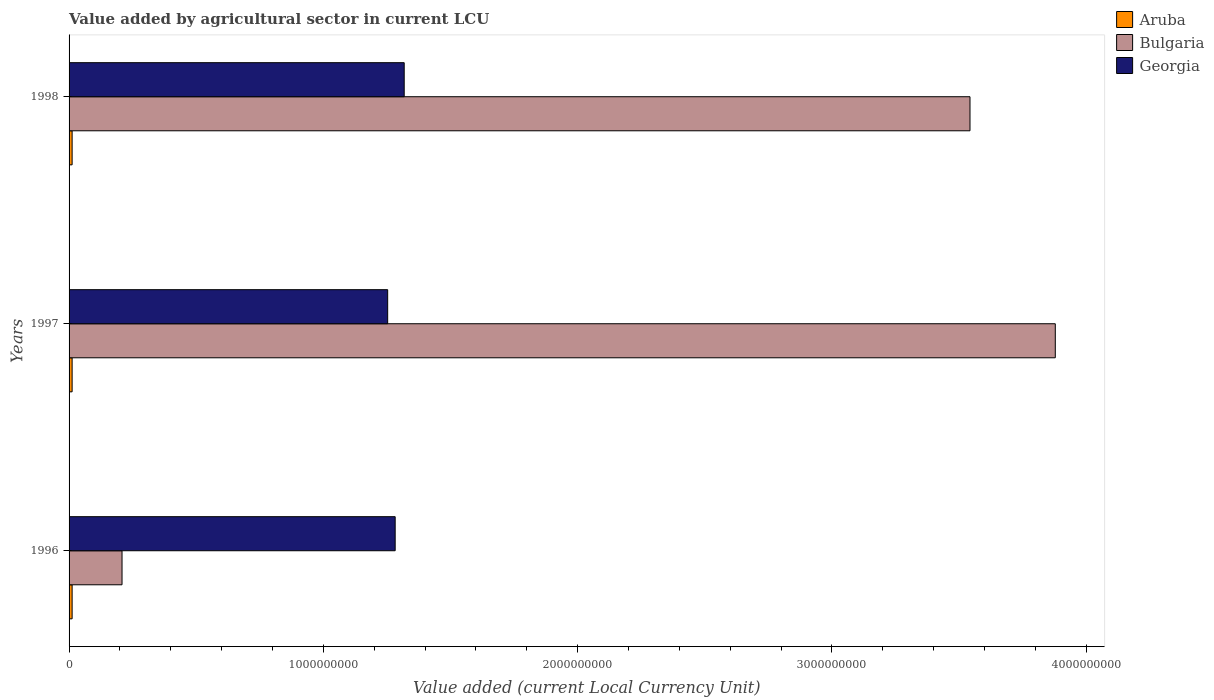How many different coloured bars are there?
Ensure brevity in your answer.  3. How many groups of bars are there?
Provide a succinct answer. 3. Are the number of bars per tick equal to the number of legend labels?
Offer a very short reply. Yes. Are the number of bars on each tick of the Y-axis equal?
Give a very brief answer. Yes. How many bars are there on the 1st tick from the top?
Your response must be concise. 3. What is the label of the 2nd group of bars from the top?
Provide a short and direct response. 1997. What is the value added by agricultural sector in Bulgaria in 1996?
Offer a very short reply. 2.08e+08. In which year was the value added by agricultural sector in Georgia maximum?
Keep it short and to the point. 1998. In which year was the value added by agricultural sector in Georgia minimum?
Ensure brevity in your answer.  1997. What is the total value added by agricultural sector in Bulgaria in the graph?
Provide a succinct answer. 7.63e+09. What is the difference between the value added by agricultural sector in Georgia in 1997 and that in 1998?
Your answer should be compact. -6.50e+07. What is the difference between the value added by agricultural sector in Bulgaria in 1997 and the value added by agricultural sector in Georgia in 1998?
Ensure brevity in your answer.  2.56e+09. What is the average value added by agricultural sector in Bulgaria per year?
Your response must be concise. 2.54e+09. In the year 1998, what is the difference between the value added by agricultural sector in Aruba and value added by agricultural sector in Georgia?
Provide a short and direct response. -1.31e+09. In how many years, is the value added by agricultural sector in Bulgaria greater than 1400000000 LCU?
Offer a terse response. 2. What is the ratio of the value added by agricultural sector in Aruba in 1996 to that in 1998?
Offer a very short reply. 1. Is the value added by agricultural sector in Georgia in 1997 less than that in 1998?
Ensure brevity in your answer.  Yes. Is the difference between the value added by agricultural sector in Aruba in 1997 and 1998 greater than the difference between the value added by agricultural sector in Georgia in 1997 and 1998?
Your answer should be compact. Yes. What is the difference between the highest and the second highest value added by agricultural sector in Bulgaria?
Keep it short and to the point. 3.35e+08. In how many years, is the value added by agricultural sector in Georgia greater than the average value added by agricultural sector in Georgia taken over all years?
Make the answer very short. 1. What does the 1st bar from the top in 1996 represents?
Your answer should be compact. Georgia. What does the 3rd bar from the bottom in 1998 represents?
Ensure brevity in your answer.  Georgia. Is it the case that in every year, the sum of the value added by agricultural sector in Aruba and value added by agricultural sector in Georgia is greater than the value added by agricultural sector in Bulgaria?
Make the answer very short. No. How many bars are there?
Provide a short and direct response. 9. Are all the bars in the graph horizontal?
Keep it short and to the point. Yes. What is the difference between two consecutive major ticks on the X-axis?
Your response must be concise. 1.00e+09. Are the values on the major ticks of X-axis written in scientific E-notation?
Offer a very short reply. No. Does the graph contain any zero values?
Your answer should be compact. No. Does the graph contain grids?
Ensure brevity in your answer.  No. Where does the legend appear in the graph?
Ensure brevity in your answer.  Top right. What is the title of the graph?
Your answer should be compact. Value added by agricultural sector in current LCU. What is the label or title of the X-axis?
Offer a very short reply. Value added (current Local Currency Unit). What is the Value added (current Local Currency Unit) in Aruba in 1996?
Offer a terse response. 1.20e+07. What is the Value added (current Local Currency Unit) of Bulgaria in 1996?
Your answer should be very brief. 2.08e+08. What is the Value added (current Local Currency Unit) of Georgia in 1996?
Your answer should be very brief. 1.28e+09. What is the Value added (current Local Currency Unit) in Aruba in 1997?
Offer a terse response. 1.20e+07. What is the Value added (current Local Currency Unit) of Bulgaria in 1997?
Offer a terse response. 3.88e+09. What is the Value added (current Local Currency Unit) in Georgia in 1997?
Provide a short and direct response. 1.25e+09. What is the Value added (current Local Currency Unit) in Bulgaria in 1998?
Offer a very short reply. 3.54e+09. What is the Value added (current Local Currency Unit) in Georgia in 1998?
Provide a short and direct response. 1.32e+09. Across all years, what is the maximum Value added (current Local Currency Unit) of Bulgaria?
Your answer should be compact. 3.88e+09. Across all years, what is the maximum Value added (current Local Currency Unit) in Georgia?
Make the answer very short. 1.32e+09. Across all years, what is the minimum Value added (current Local Currency Unit) of Bulgaria?
Keep it short and to the point. 2.08e+08. Across all years, what is the minimum Value added (current Local Currency Unit) in Georgia?
Offer a very short reply. 1.25e+09. What is the total Value added (current Local Currency Unit) in Aruba in the graph?
Make the answer very short. 3.60e+07. What is the total Value added (current Local Currency Unit) in Bulgaria in the graph?
Give a very brief answer. 7.63e+09. What is the total Value added (current Local Currency Unit) of Georgia in the graph?
Provide a succinct answer. 3.85e+09. What is the difference between the Value added (current Local Currency Unit) of Aruba in 1996 and that in 1997?
Ensure brevity in your answer.  0. What is the difference between the Value added (current Local Currency Unit) in Bulgaria in 1996 and that in 1997?
Make the answer very short. -3.67e+09. What is the difference between the Value added (current Local Currency Unit) of Georgia in 1996 and that in 1997?
Your answer should be very brief. 2.95e+07. What is the difference between the Value added (current Local Currency Unit) of Aruba in 1996 and that in 1998?
Your answer should be very brief. 0. What is the difference between the Value added (current Local Currency Unit) in Bulgaria in 1996 and that in 1998?
Your response must be concise. -3.33e+09. What is the difference between the Value added (current Local Currency Unit) of Georgia in 1996 and that in 1998?
Provide a succinct answer. -3.55e+07. What is the difference between the Value added (current Local Currency Unit) of Aruba in 1997 and that in 1998?
Your answer should be very brief. 0. What is the difference between the Value added (current Local Currency Unit) of Bulgaria in 1997 and that in 1998?
Offer a terse response. 3.35e+08. What is the difference between the Value added (current Local Currency Unit) in Georgia in 1997 and that in 1998?
Make the answer very short. -6.50e+07. What is the difference between the Value added (current Local Currency Unit) of Aruba in 1996 and the Value added (current Local Currency Unit) of Bulgaria in 1997?
Ensure brevity in your answer.  -3.87e+09. What is the difference between the Value added (current Local Currency Unit) of Aruba in 1996 and the Value added (current Local Currency Unit) of Georgia in 1997?
Your answer should be very brief. -1.24e+09. What is the difference between the Value added (current Local Currency Unit) of Bulgaria in 1996 and the Value added (current Local Currency Unit) of Georgia in 1997?
Ensure brevity in your answer.  -1.04e+09. What is the difference between the Value added (current Local Currency Unit) in Aruba in 1996 and the Value added (current Local Currency Unit) in Bulgaria in 1998?
Your response must be concise. -3.53e+09. What is the difference between the Value added (current Local Currency Unit) in Aruba in 1996 and the Value added (current Local Currency Unit) in Georgia in 1998?
Your answer should be compact. -1.31e+09. What is the difference between the Value added (current Local Currency Unit) in Bulgaria in 1996 and the Value added (current Local Currency Unit) in Georgia in 1998?
Provide a short and direct response. -1.11e+09. What is the difference between the Value added (current Local Currency Unit) in Aruba in 1997 and the Value added (current Local Currency Unit) in Bulgaria in 1998?
Your answer should be very brief. -3.53e+09. What is the difference between the Value added (current Local Currency Unit) of Aruba in 1997 and the Value added (current Local Currency Unit) of Georgia in 1998?
Offer a very short reply. -1.31e+09. What is the difference between the Value added (current Local Currency Unit) of Bulgaria in 1997 and the Value added (current Local Currency Unit) of Georgia in 1998?
Provide a short and direct response. 2.56e+09. What is the average Value added (current Local Currency Unit) of Bulgaria per year?
Ensure brevity in your answer.  2.54e+09. What is the average Value added (current Local Currency Unit) in Georgia per year?
Your response must be concise. 1.28e+09. In the year 1996, what is the difference between the Value added (current Local Currency Unit) in Aruba and Value added (current Local Currency Unit) in Bulgaria?
Give a very brief answer. -1.96e+08. In the year 1996, what is the difference between the Value added (current Local Currency Unit) in Aruba and Value added (current Local Currency Unit) in Georgia?
Give a very brief answer. -1.27e+09. In the year 1996, what is the difference between the Value added (current Local Currency Unit) of Bulgaria and Value added (current Local Currency Unit) of Georgia?
Offer a terse response. -1.07e+09. In the year 1997, what is the difference between the Value added (current Local Currency Unit) in Aruba and Value added (current Local Currency Unit) in Bulgaria?
Provide a succinct answer. -3.87e+09. In the year 1997, what is the difference between the Value added (current Local Currency Unit) of Aruba and Value added (current Local Currency Unit) of Georgia?
Ensure brevity in your answer.  -1.24e+09. In the year 1997, what is the difference between the Value added (current Local Currency Unit) of Bulgaria and Value added (current Local Currency Unit) of Georgia?
Provide a succinct answer. 2.63e+09. In the year 1998, what is the difference between the Value added (current Local Currency Unit) of Aruba and Value added (current Local Currency Unit) of Bulgaria?
Provide a succinct answer. -3.53e+09. In the year 1998, what is the difference between the Value added (current Local Currency Unit) of Aruba and Value added (current Local Currency Unit) of Georgia?
Ensure brevity in your answer.  -1.31e+09. In the year 1998, what is the difference between the Value added (current Local Currency Unit) in Bulgaria and Value added (current Local Currency Unit) in Georgia?
Make the answer very short. 2.23e+09. What is the ratio of the Value added (current Local Currency Unit) of Aruba in 1996 to that in 1997?
Offer a terse response. 1. What is the ratio of the Value added (current Local Currency Unit) of Bulgaria in 1996 to that in 1997?
Offer a very short reply. 0.05. What is the ratio of the Value added (current Local Currency Unit) in Georgia in 1996 to that in 1997?
Your answer should be compact. 1.02. What is the ratio of the Value added (current Local Currency Unit) of Bulgaria in 1996 to that in 1998?
Provide a succinct answer. 0.06. What is the ratio of the Value added (current Local Currency Unit) of Georgia in 1996 to that in 1998?
Provide a short and direct response. 0.97. What is the ratio of the Value added (current Local Currency Unit) of Bulgaria in 1997 to that in 1998?
Your answer should be very brief. 1.09. What is the ratio of the Value added (current Local Currency Unit) of Georgia in 1997 to that in 1998?
Give a very brief answer. 0.95. What is the difference between the highest and the second highest Value added (current Local Currency Unit) of Aruba?
Offer a very short reply. 0. What is the difference between the highest and the second highest Value added (current Local Currency Unit) of Bulgaria?
Keep it short and to the point. 3.35e+08. What is the difference between the highest and the second highest Value added (current Local Currency Unit) in Georgia?
Provide a succinct answer. 3.55e+07. What is the difference between the highest and the lowest Value added (current Local Currency Unit) in Bulgaria?
Offer a terse response. 3.67e+09. What is the difference between the highest and the lowest Value added (current Local Currency Unit) in Georgia?
Provide a short and direct response. 6.50e+07. 